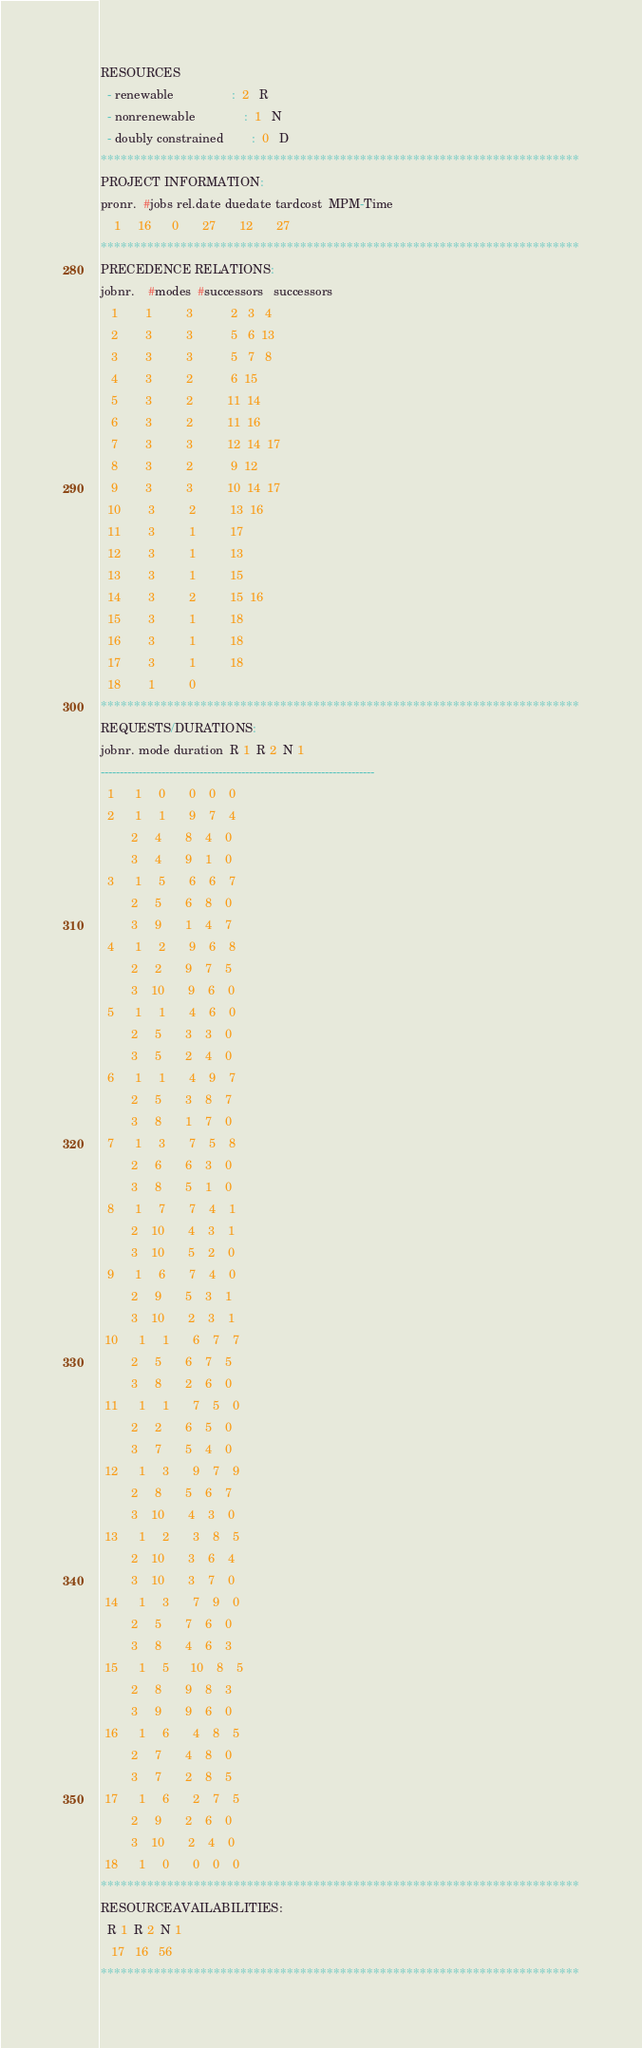Convert code to text. <code><loc_0><loc_0><loc_500><loc_500><_ObjectiveC_>RESOURCES
  - renewable                 :  2   R
  - nonrenewable              :  1   N
  - doubly constrained        :  0   D
************************************************************************
PROJECT INFORMATION:
pronr.  #jobs rel.date duedate tardcost  MPM-Time
    1     16      0       27       12       27
************************************************************************
PRECEDENCE RELATIONS:
jobnr.    #modes  #successors   successors
   1        1          3           2   3   4
   2        3          3           5   6  13
   3        3          3           5   7   8
   4        3          2           6  15
   5        3          2          11  14
   6        3          2          11  16
   7        3          3          12  14  17
   8        3          2           9  12
   9        3          3          10  14  17
  10        3          2          13  16
  11        3          1          17
  12        3          1          13
  13        3          1          15
  14        3          2          15  16
  15        3          1          18
  16        3          1          18
  17        3          1          18
  18        1          0        
************************************************************************
REQUESTS/DURATIONS:
jobnr. mode duration  R 1  R 2  N 1
------------------------------------------------------------------------
  1      1     0       0    0    0
  2      1     1       9    7    4
         2     4       8    4    0
         3     4       9    1    0
  3      1     5       6    6    7
         2     5       6    8    0
         3     9       1    4    7
  4      1     2       9    6    8
         2     2       9    7    5
         3    10       9    6    0
  5      1     1       4    6    0
         2     5       3    3    0
         3     5       2    4    0
  6      1     1       4    9    7
         2     5       3    8    7
         3     8       1    7    0
  7      1     3       7    5    8
         2     6       6    3    0
         3     8       5    1    0
  8      1     7       7    4    1
         2    10       4    3    1
         3    10       5    2    0
  9      1     6       7    4    0
         2     9       5    3    1
         3    10       2    3    1
 10      1     1       6    7    7
         2     5       6    7    5
         3     8       2    6    0
 11      1     1       7    5    0
         2     2       6    5    0
         3     7       5    4    0
 12      1     3       9    7    9
         2     8       5    6    7
         3    10       4    3    0
 13      1     2       3    8    5
         2    10       3    6    4
         3    10       3    7    0
 14      1     3       7    9    0
         2     5       7    6    0
         3     8       4    6    3
 15      1     5      10    8    5
         2     8       9    8    3
         3     9       9    6    0
 16      1     6       4    8    5
         2     7       4    8    0
         3     7       2    8    5
 17      1     6       2    7    5
         2     9       2    6    0
         3    10       2    4    0
 18      1     0       0    0    0
************************************************************************
RESOURCEAVAILABILITIES:
  R 1  R 2  N 1
   17   16   56
************************************************************************
</code> 